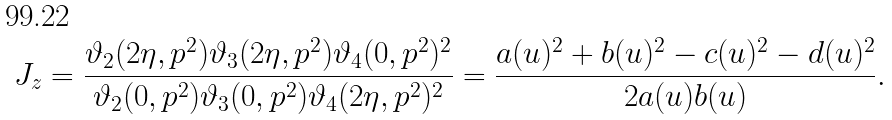<formula> <loc_0><loc_0><loc_500><loc_500>J _ { z } = \frac { \vartheta _ { 2 } ( 2 \eta , p ^ { 2 } ) \vartheta _ { 3 } ( 2 \eta , p ^ { 2 } ) \vartheta _ { 4 } ( 0 , p ^ { 2 } ) ^ { 2 } } { \vartheta _ { 2 } ( 0 , p ^ { 2 } ) \vartheta _ { 3 } ( 0 , p ^ { 2 } ) \vartheta _ { 4 } ( 2 \eta , p ^ { 2 } ) ^ { 2 } } = \frac { a ( u ) ^ { 2 } + b ( u ) ^ { 2 } - c ( u ) ^ { 2 } - d ( u ) ^ { 2 } } { 2 a ( u ) b ( u ) } .</formula> 